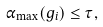<formula> <loc_0><loc_0><loc_500><loc_500>\alpha _ { \max } ( g _ { i } ) \leq \tau ,</formula> 